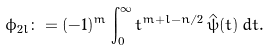<formula> <loc_0><loc_0><loc_500><loc_500>\phi _ { 2 l } \colon = ( - 1 ) ^ { m } \int _ { 0 } ^ { \infty } t ^ { m + l - n / 2 } \, \hat { \psi } ( t ) \, d t .</formula> 